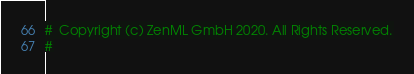Convert code to text. <code><loc_0><loc_0><loc_500><loc_500><_Python_>#  Copyright (c) ZenML GmbH 2020. All Rights Reserved.
#</code> 